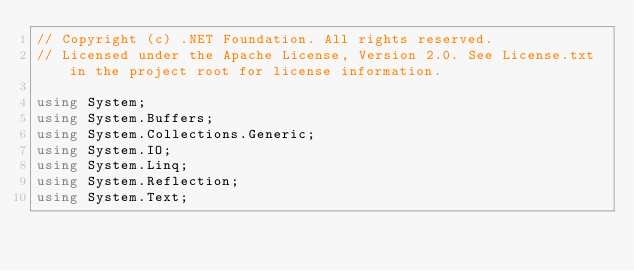<code> <loc_0><loc_0><loc_500><loc_500><_C#_>// Copyright (c) .NET Foundation. All rights reserved.
// Licensed under the Apache License, Version 2.0. See License.txt in the project root for license information.

using System;
using System.Buffers;
using System.Collections.Generic;
using System.IO;
using System.Linq;
using System.Reflection;
using System.Text;</code> 